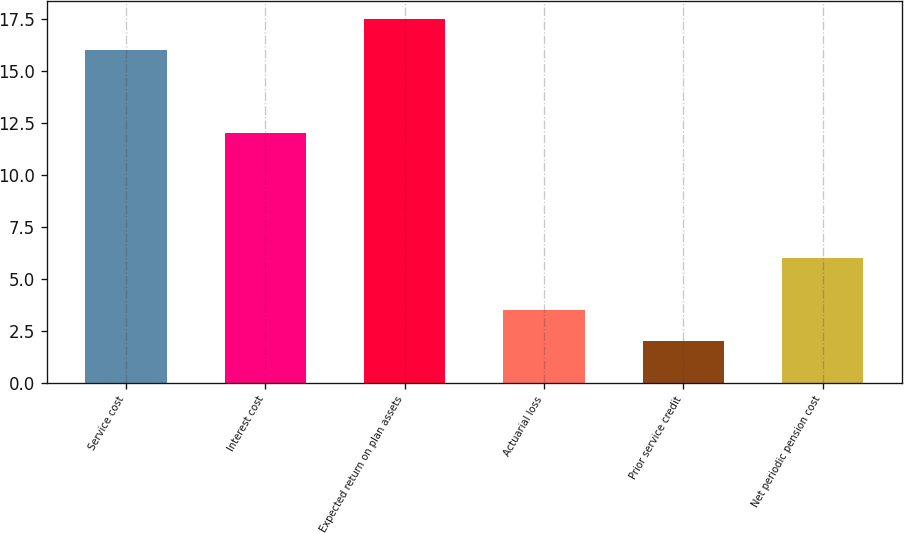<chart> <loc_0><loc_0><loc_500><loc_500><bar_chart><fcel>Service cost<fcel>Interest cost<fcel>Expected return on plan assets<fcel>Actuarial loss<fcel>Prior service credit<fcel>Net periodic pension cost<nl><fcel>16<fcel>12<fcel>17.5<fcel>3.5<fcel>2<fcel>6<nl></chart> 